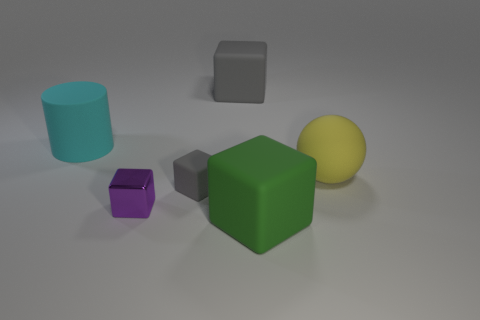Are there any patterns or textures on the objects, or are they all solid colors? All the objects in the image appear to have a smooth and matte finish with no visible patterns or textures. They all consist of solid colors.  In terms of lighting, where does the light source seem to be coming from in the image? The light source in the image appears to be coming from the upper right-hand side, as indicated by the shadows extended to the left of the objects and the highlights visible on the right sides of the objects. 